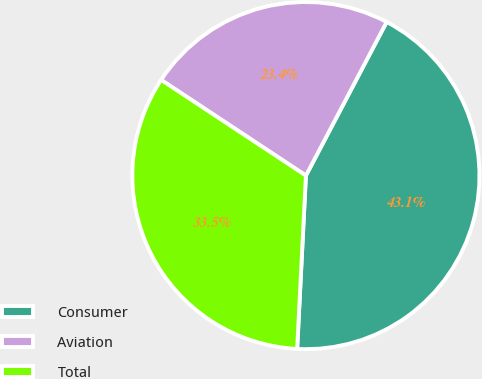Convert chart. <chart><loc_0><loc_0><loc_500><loc_500><pie_chart><fcel>Consumer<fcel>Aviation<fcel>Total<nl><fcel>43.1%<fcel>23.41%<fcel>33.49%<nl></chart> 